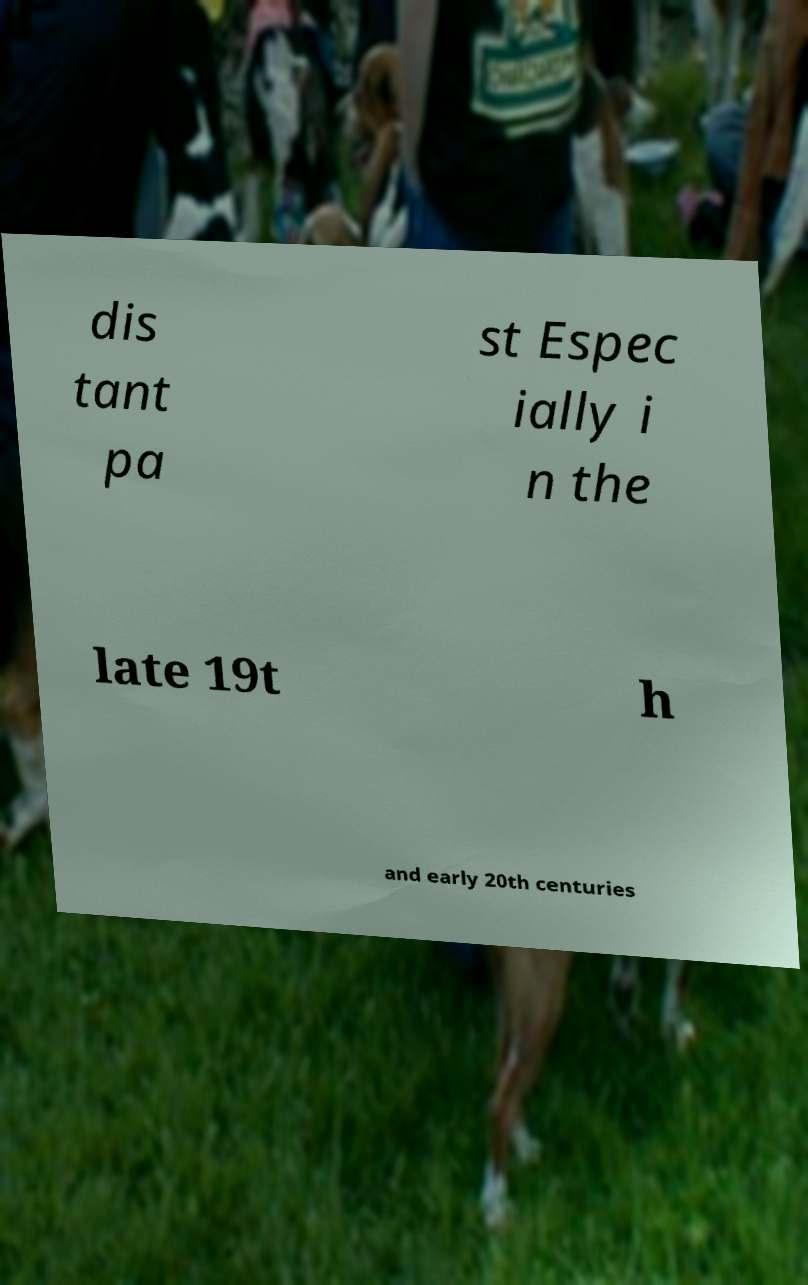For documentation purposes, I need the text within this image transcribed. Could you provide that? dis tant pa st Espec ially i n the late 19t h and early 20th centuries 